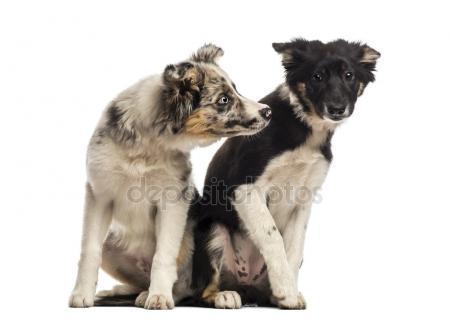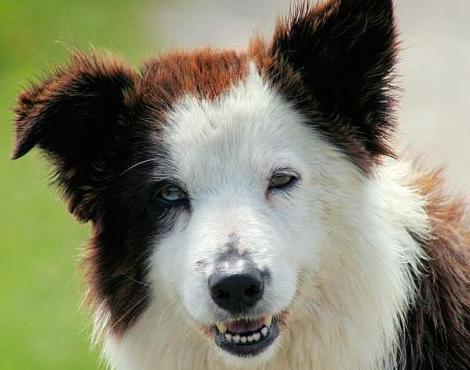The first image is the image on the left, the second image is the image on the right. Assess this claim about the two images: "The right image contains exactly two dogs.". Correct or not? Answer yes or no. No. The first image is the image on the left, the second image is the image on the right. Given the left and right images, does the statement "Exactly two dogs are lying together in one of the images." hold true? Answer yes or no. No. 